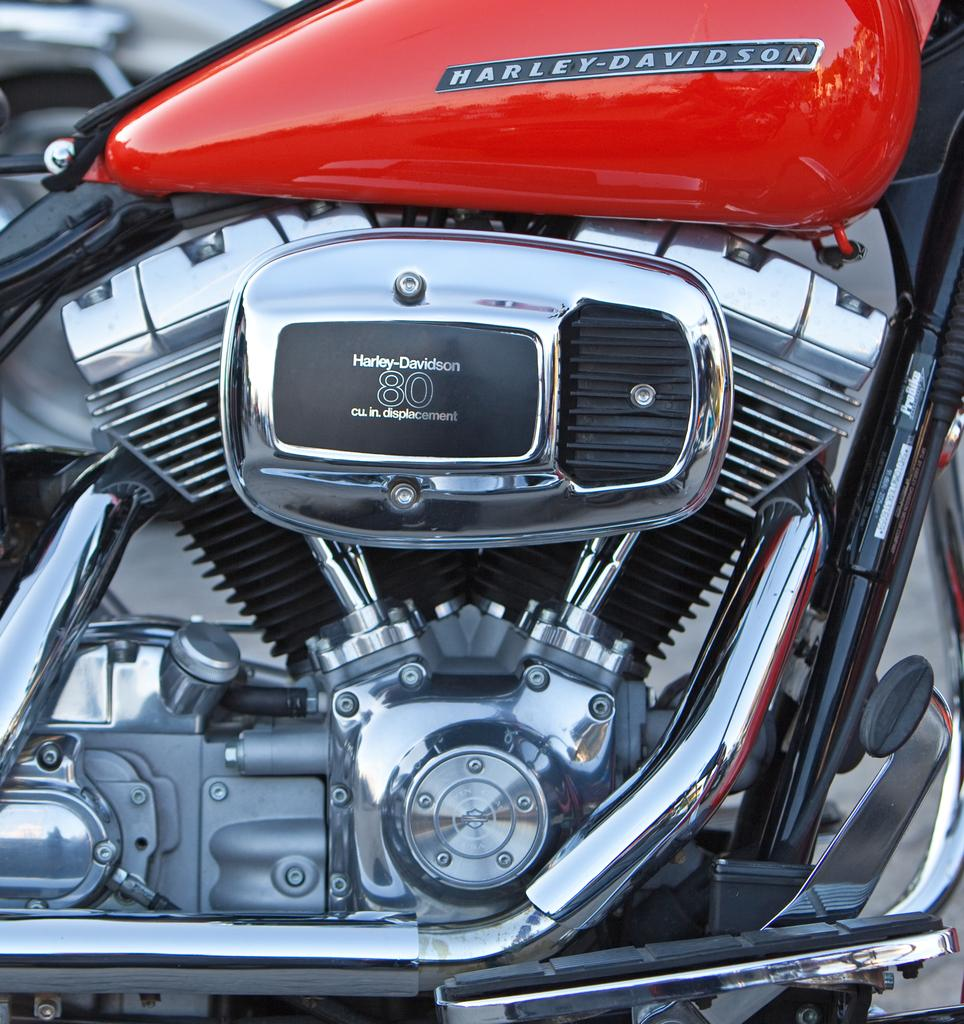What type of vehicle is in the image? There is a motorbike in the image. What colors can be seen on the motorbike? The motorbike has red, silver, and black colors. What brand is the motorbike? The name "Harley-Davidson" is written on the motorbike. How would you describe the background of the image? The background of the image is blurred. Is there a fire burning near the motorbike in the image? No, there is no fire present in the image. What type of bed is visible in the image? There is no bed present in the image; it features a motorbike. 